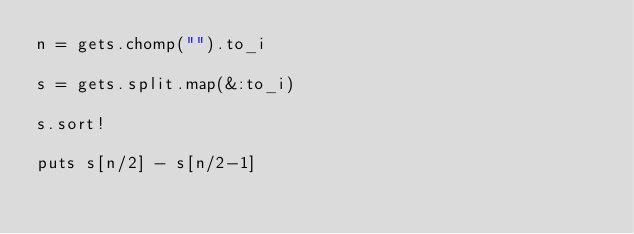<code> <loc_0><loc_0><loc_500><loc_500><_Ruby_>n = gets.chomp("").to_i

s = gets.split.map(&:to_i)

s.sort!

puts s[n/2] - s[n/2-1]
</code> 